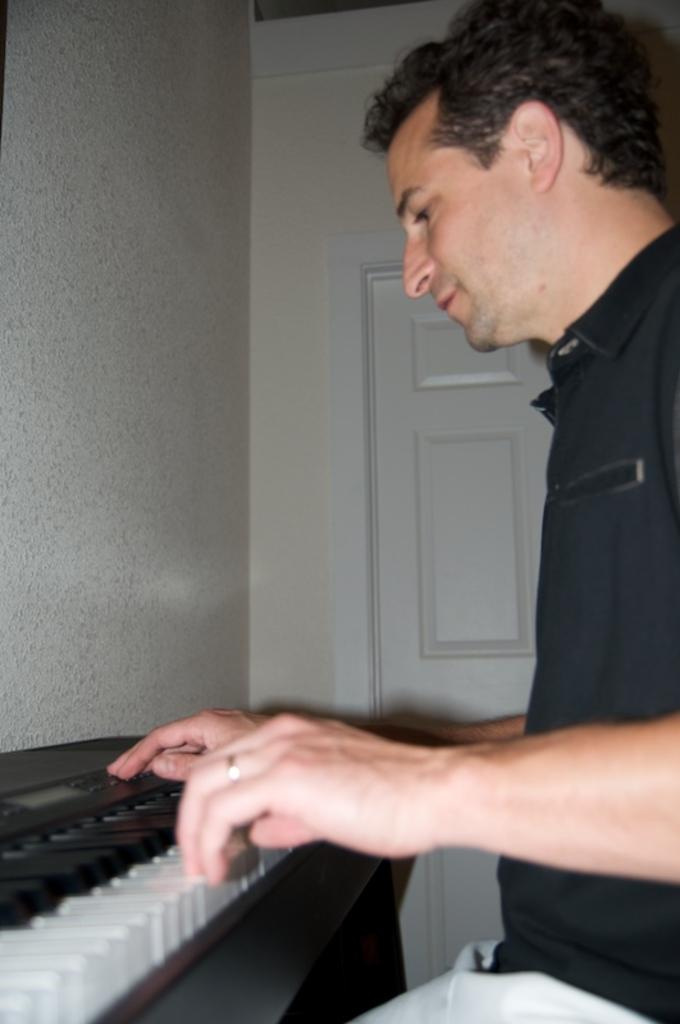What is the person in the image doing? The person is sitting in front of the piano. What can be seen in the background of the image? There is a wall and a door in the background of the image. What type of cakes is the person eating while playing the piano in the image? There is no indication in the image that the person is eating any cakes, so it cannot be determined from the picture. 